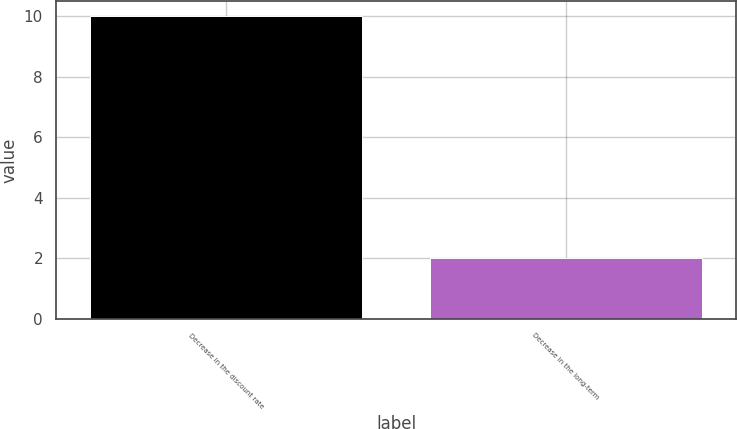Convert chart to OTSL. <chart><loc_0><loc_0><loc_500><loc_500><bar_chart><fcel>Decrease in the discount rate<fcel>Decrease in the long-term<nl><fcel>10<fcel>2<nl></chart> 